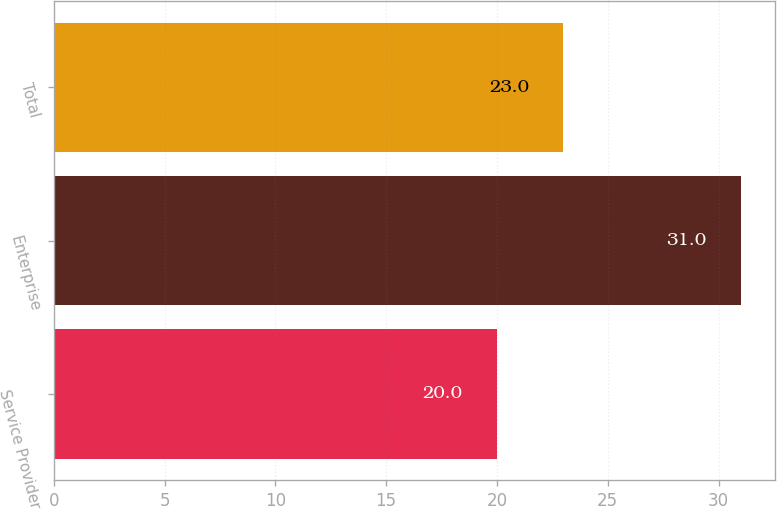Convert chart to OTSL. <chart><loc_0><loc_0><loc_500><loc_500><bar_chart><fcel>Service Provider<fcel>Enterprise<fcel>Total<nl><fcel>20<fcel>31<fcel>23<nl></chart> 